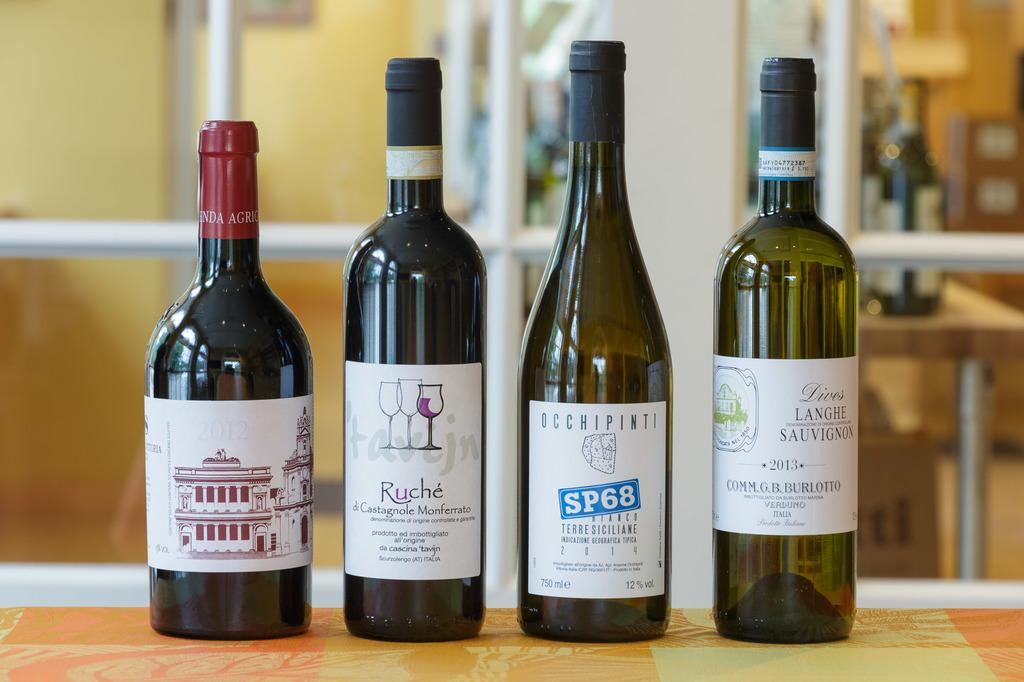Provide a one-sentence caption for the provided image. Four wines on a table and featuring the brands Ruche and SP68. 